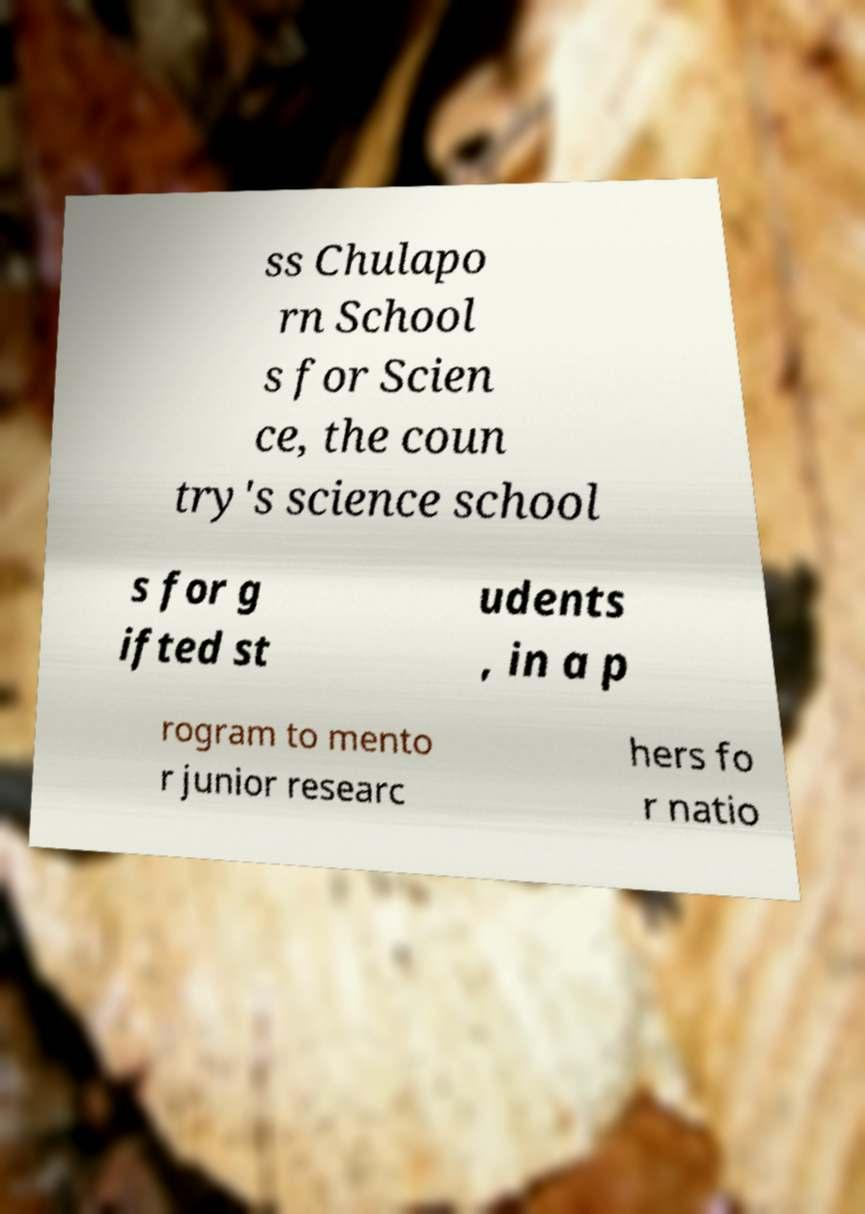There's text embedded in this image that I need extracted. Can you transcribe it verbatim? ss Chulapo rn School s for Scien ce, the coun try's science school s for g ifted st udents , in a p rogram to mento r junior researc hers fo r natio 